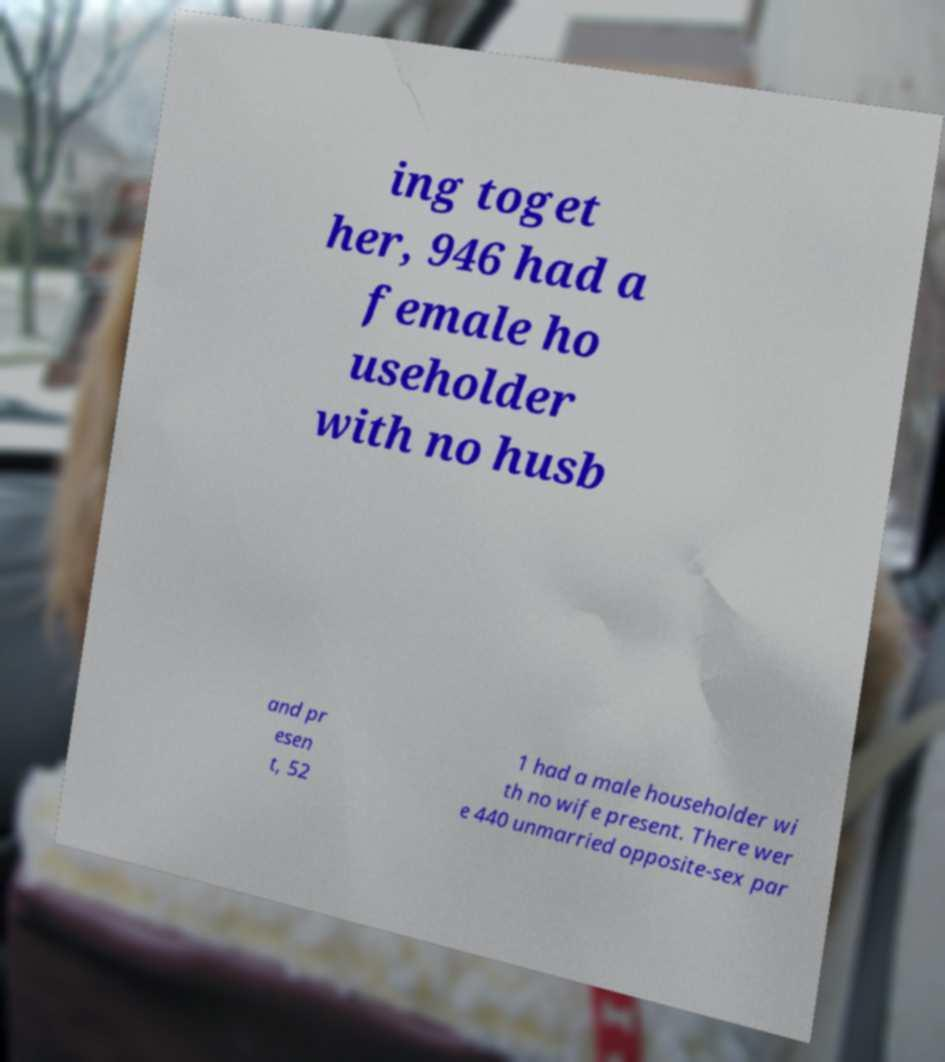Could you assist in decoding the text presented in this image and type it out clearly? ing toget her, 946 had a female ho useholder with no husb and pr esen t, 52 1 had a male householder wi th no wife present. There wer e 440 unmarried opposite-sex par 